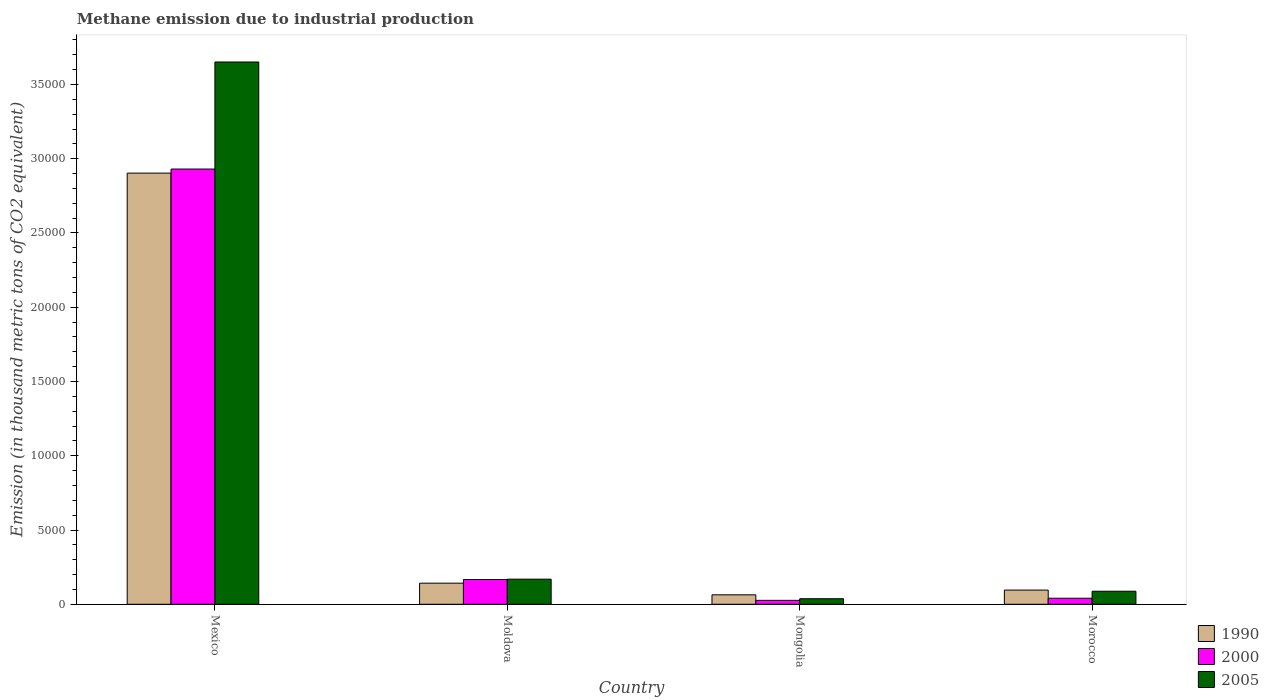How many different coloured bars are there?
Give a very brief answer. 3. How many groups of bars are there?
Your response must be concise. 4. What is the label of the 4th group of bars from the left?
Make the answer very short. Morocco. In how many cases, is the number of bars for a given country not equal to the number of legend labels?
Offer a very short reply. 0. What is the amount of methane emitted in 2000 in Mongolia?
Your answer should be very brief. 264.8. Across all countries, what is the maximum amount of methane emitted in 1990?
Your answer should be very brief. 2.90e+04. Across all countries, what is the minimum amount of methane emitted in 2000?
Offer a very short reply. 264.8. In which country was the amount of methane emitted in 2000 minimum?
Your answer should be very brief. Mongolia. What is the total amount of methane emitted in 1990 in the graph?
Your response must be concise. 3.20e+04. What is the difference between the amount of methane emitted in 1990 in Mexico and that in Moldova?
Your answer should be compact. 2.76e+04. What is the difference between the amount of methane emitted in 2000 in Moldova and the amount of methane emitted in 1990 in Morocco?
Give a very brief answer. 713.1. What is the average amount of methane emitted in 1990 per country?
Ensure brevity in your answer.  8011.43. What is the difference between the amount of methane emitted of/in 2000 and amount of methane emitted of/in 1990 in Mongolia?
Your answer should be very brief. -371.7. What is the ratio of the amount of methane emitted in 2000 in Moldova to that in Morocco?
Give a very brief answer. 4.09. Is the amount of methane emitted in 1990 in Moldova less than that in Mongolia?
Provide a succinct answer. No. What is the difference between the highest and the second highest amount of methane emitted in 1990?
Offer a very short reply. -466.9. What is the difference between the highest and the lowest amount of methane emitted in 2000?
Your response must be concise. 2.90e+04. What does the 2nd bar from the left in Morocco represents?
Provide a short and direct response. 2000. What does the 1st bar from the right in Mongolia represents?
Provide a short and direct response. 2005. Is it the case that in every country, the sum of the amount of methane emitted in 2000 and amount of methane emitted in 1990 is greater than the amount of methane emitted in 2005?
Provide a short and direct response. Yes. How many bars are there?
Your answer should be very brief. 12. Are all the bars in the graph horizontal?
Make the answer very short. No. Are the values on the major ticks of Y-axis written in scientific E-notation?
Your response must be concise. No. Does the graph contain any zero values?
Provide a succinct answer. No. Where does the legend appear in the graph?
Your response must be concise. Bottom right. What is the title of the graph?
Give a very brief answer. Methane emission due to industrial production. What is the label or title of the X-axis?
Your response must be concise. Country. What is the label or title of the Y-axis?
Offer a terse response. Emission (in thousand metric tons of CO2 equivalent). What is the Emission (in thousand metric tons of CO2 equivalent) in 1990 in Mexico?
Offer a very short reply. 2.90e+04. What is the Emission (in thousand metric tons of CO2 equivalent) in 2000 in Mexico?
Your response must be concise. 2.93e+04. What is the Emission (in thousand metric tons of CO2 equivalent) of 2005 in Mexico?
Ensure brevity in your answer.  3.65e+04. What is the Emission (in thousand metric tons of CO2 equivalent) of 1990 in Moldova?
Provide a succinct answer. 1422.3. What is the Emission (in thousand metric tons of CO2 equivalent) in 2000 in Moldova?
Offer a terse response. 1668.5. What is the Emission (in thousand metric tons of CO2 equivalent) in 2005 in Moldova?
Provide a short and direct response. 1691.1. What is the Emission (in thousand metric tons of CO2 equivalent) of 1990 in Mongolia?
Your answer should be very brief. 636.5. What is the Emission (in thousand metric tons of CO2 equivalent) of 2000 in Mongolia?
Offer a very short reply. 264.8. What is the Emission (in thousand metric tons of CO2 equivalent) of 2005 in Mongolia?
Your answer should be compact. 373.5. What is the Emission (in thousand metric tons of CO2 equivalent) in 1990 in Morocco?
Your answer should be very brief. 955.4. What is the Emission (in thousand metric tons of CO2 equivalent) of 2000 in Morocco?
Offer a very short reply. 407.6. What is the Emission (in thousand metric tons of CO2 equivalent) in 2005 in Morocco?
Keep it short and to the point. 877.7. Across all countries, what is the maximum Emission (in thousand metric tons of CO2 equivalent) in 1990?
Make the answer very short. 2.90e+04. Across all countries, what is the maximum Emission (in thousand metric tons of CO2 equivalent) of 2000?
Keep it short and to the point. 2.93e+04. Across all countries, what is the maximum Emission (in thousand metric tons of CO2 equivalent) of 2005?
Your answer should be very brief. 3.65e+04. Across all countries, what is the minimum Emission (in thousand metric tons of CO2 equivalent) in 1990?
Offer a very short reply. 636.5. Across all countries, what is the minimum Emission (in thousand metric tons of CO2 equivalent) of 2000?
Offer a terse response. 264.8. Across all countries, what is the minimum Emission (in thousand metric tons of CO2 equivalent) in 2005?
Your response must be concise. 373.5. What is the total Emission (in thousand metric tons of CO2 equivalent) in 1990 in the graph?
Your answer should be compact. 3.20e+04. What is the total Emission (in thousand metric tons of CO2 equivalent) in 2000 in the graph?
Offer a terse response. 3.16e+04. What is the total Emission (in thousand metric tons of CO2 equivalent) in 2005 in the graph?
Make the answer very short. 3.95e+04. What is the difference between the Emission (in thousand metric tons of CO2 equivalent) in 1990 in Mexico and that in Moldova?
Provide a succinct answer. 2.76e+04. What is the difference between the Emission (in thousand metric tons of CO2 equivalent) of 2000 in Mexico and that in Moldova?
Your answer should be very brief. 2.76e+04. What is the difference between the Emission (in thousand metric tons of CO2 equivalent) of 2005 in Mexico and that in Moldova?
Offer a very short reply. 3.48e+04. What is the difference between the Emission (in thousand metric tons of CO2 equivalent) of 1990 in Mexico and that in Mongolia?
Provide a succinct answer. 2.84e+04. What is the difference between the Emission (in thousand metric tons of CO2 equivalent) of 2000 in Mexico and that in Mongolia?
Your answer should be compact. 2.90e+04. What is the difference between the Emission (in thousand metric tons of CO2 equivalent) of 2005 in Mexico and that in Mongolia?
Give a very brief answer. 3.61e+04. What is the difference between the Emission (in thousand metric tons of CO2 equivalent) of 1990 in Mexico and that in Morocco?
Give a very brief answer. 2.81e+04. What is the difference between the Emission (in thousand metric tons of CO2 equivalent) in 2000 in Mexico and that in Morocco?
Provide a succinct answer. 2.89e+04. What is the difference between the Emission (in thousand metric tons of CO2 equivalent) of 2005 in Mexico and that in Morocco?
Your answer should be very brief. 3.56e+04. What is the difference between the Emission (in thousand metric tons of CO2 equivalent) of 1990 in Moldova and that in Mongolia?
Ensure brevity in your answer.  785.8. What is the difference between the Emission (in thousand metric tons of CO2 equivalent) of 2000 in Moldova and that in Mongolia?
Make the answer very short. 1403.7. What is the difference between the Emission (in thousand metric tons of CO2 equivalent) in 2005 in Moldova and that in Mongolia?
Offer a terse response. 1317.6. What is the difference between the Emission (in thousand metric tons of CO2 equivalent) in 1990 in Moldova and that in Morocco?
Provide a succinct answer. 466.9. What is the difference between the Emission (in thousand metric tons of CO2 equivalent) of 2000 in Moldova and that in Morocco?
Your answer should be compact. 1260.9. What is the difference between the Emission (in thousand metric tons of CO2 equivalent) in 2005 in Moldova and that in Morocco?
Provide a succinct answer. 813.4. What is the difference between the Emission (in thousand metric tons of CO2 equivalent) of 1990 in Mongolia and that in Morocco?
Provide a succinct answer. -318.9. What is the difference between the Emission (in thousand metric tons of CO2 equivalent) in 2000 in Mongolia and that in Morocco?
Give a very brief answer. -142.8. What is the difference between the Emission (in thousand metric tons of CO2 equivalent) of 2005 in Mongolia and that in Morocco?
Your response must be concise. -504.2. What is the difference between the Emission (in thousand metric tons of CO2 equivalent) of 1990 in Mexico and the Emission (in thousand metric tons of CO2 equivalent) of 2000 in Moldova?
Ensure brevity in your answer.  2.74e+04. What is the difference between the Emission (in thousand metric tons of CO2 equivalent) in 1990 in Mexico and the Emission (in thousand metric tons of CO2 equivalent) in 2005 in Moldova?
Make the answer very short. 2.73e+04. What is the difference between the Emission (in thousand metric tons of CO2 equivalent) in 2000 in Mexico and the Emission (in thousand metric tons of CO2 equivalent) in 2005 in Moldova?
Your answer should be compact. 2.76e+04. What is the difference between the Emission (in thousand metric tons of CO2 equivalent) of 1990 in Mexico and the Emission (in thousand metric tons of CO2 equivalent) of 2000 in Mongolia?
Offer a terse response. 2.88e+04. What is the difference between the Emission (in thousand metric tons of CO2 equivalent) of 1990 in Mexico and the Emission (in thousand metric tons of CO2 equivalent) of 2005 in Mongolia?
Your answer should be very brief. 2.87e+04. What is the difference between the Emission (in thousand metric tons of CO2 equivalent) in 2000 in Mexico and the Emission (in thousand metric tons of CO2 equivalent) in 2005 in Mongolia?
Offer a terse response. 2.89e+04. What is the difference between the Emission (in thousand metric tons of CO2 equivalent) in 1990 in Mexico and the Emission (in thousand metric tons of CO2 equivalent) in 2000 in Morocco?
Provide a short and direct response. 2.86e+04. What is the difference between the Emission (in thousand metric tons of CO2 equivalent) in 1990 in Mexico and the Emission (in thousand metric tons of CO2 equivalent) in 2005 in Morocco?
Ensure brevity in your answer.  2.82e+04. What is the difference between the Emission (in thousand metric tons of CO2 equivalent) in 2000 in Mexico and the Emission (in thousand metric tons of CO2 equivalent) in 2005 in Morocco?
Ensure brevity in your answer.  2.84e+04. What is the difference between the Emission (in thousand metric tons of CO2 equivalent) of 1990 in Moldova and the Emission (in thousand metric tons of CO2 equivalent) of 2000 in Mongolia?
Give a very brief answer. 1157.5. What is the difference between the Emission (in thousand metric tons of CO2 equivalent) in 1990 in Moldova and the Emission (in thousand metric tons of CO2 equivalent) in 2005 in Mongolia?
Your answer should be very brief. 1048.8. What is the difference between the Emission (in thousand metric tons of CO2 equivalent) in 2000 in Moldova and the Emission (in thousand metric tons of CO2 equivalent) in 2005 in Mongolia?
Offer a terse response. 1295. What is the difference between the Emission (in thousand metric tons of CO2 equivalent) of 1990 in Moldova and the Emission (in thousand metric tons of CO2 equivalent) of 2000 in Morocco?
Your answer should be very brief. 1014.7. What is the difference between the Emission (in thousand metric tons of CO2 equivalent) in 1990 in Moldova and the Emission (in thousand metric tons of CO2 equivalent) in 2005 in Morocco?
Keep it short and to the point. 544.6. What is the difference between the Emission (in thousand metric tons of CO2 equivalent) of 2000 in Moldova and the Emission (in thousand metric tons of CO2 equivalent) of 2005 in Morocco?
Your answer should be very brief. 790.8. What is the difference between the Emission (in thousand metric tons of CO2 equivalent) of 1990 in Mongolia and the Emission (in thousand metric tons of CO2 equivalent) of 2000 in Morocco?
Your answer should be compact. 228.9. What is the difference between the Emission (in thousand metric tons of CO2 equivalent) of 1990 in Mongolia and the Emission (in thousand metric tons of CO2 equivalent) of 2005 in Morocco?
Keep it short and to the point. -241.2. What is the difference between the Emission (in thousand metric tons of CO2 equivalent) in 2000 in Mongolia and the Emission (in thousand metric tons of CO2 equivalent) in 2005 in Morocco?
Your answer should be compact. -612.9. What is the average Emission (in thousand metric tons of CO2 equivalent) of 1990 per country?
Your response must be concise. 8011.43. What is the average Emission (in thousand metric tons of CO2 equivalent) in 2000 per country?
Offer a very short reply. 7911.62. What is the average Emission (in thousand metric tons of CO2 equivalent) in 2005 per country?
Keep it short and to the point. 9863.95. What is the difference between the Emission (in thousand metric tons of CO2 equivalent) of 1990 and Emission (in thousand metric tons of CO2 equivalent) of 2000 in Mexico?
Offer a very short reply. -274.1. What is the difference between the Emission (in thousand metric tons of CO2 equivalent) in 1990 and Emission (in thousand metric tons of CO2 equivalent) in 2005 in Mexico?
Ensure brevity in your answer.  -7482. What is the difference between the Emission (in thousand metric tons of CO2 equivalent) in 2000 and Emission (in thousand metric tons of CO2 equivalent) in 2005 in Mexico?
Give a very brief answer. -7207.9. What is the difference between the Emission (in thousand metric tons of CO2 equivalent) of 1990 and Emission (in thousand metric tons of CO2 equivalent) of 2000 in Moldova?
Offer a terse response. -246.2. What is the difference between the Emission (in thousand metric tons of CO2 equivalent) in 1990 and Emission (in thousand metric tons of CO2 equivalent) in 2005 in Moldova?
Give a very brief answer. -268.8. What is the difference between the Emission (in thousand metric tons of CO2 equivalent) in 2000 and Emission (in thousand metric tons of CO2 equivalent) in 2005 in Moldova?
Make the answer very short. -22.6. What is the difference between the Emission (in thousand metric tons of CO2 equivalent) in 1990 and Emission (in thousand metric tons of CO2 equivalent) in 2000 in Mongolia?
Your answer should be very brief. 371.7. What is the difference between the Emission (in thousand metric tons of CO2 equivalent) of 1990 and Emission (in thousand metric tons of CO2 equivalent) of 2005 in Mongolia?
Ensure brevity in your answer.  263. What is the difference between the Emission (in thousand metric tons of CO2 equivalent) of 2000 and Emission (in thousand metric tons of CO2 equivalent) of 2005 in Mongolia?
Ensure brevity in your answer.  -108.7. What is the difference between the Emission (in thousand metric tons of CO2 equivalent) in 1990 and Emission (in thousand metric tons of CO2 equivalent) in 2000 in Morocco?
Make the answer very short. 547.8. What is the difference between the Emission (in thousand metric tons of CO2 equivalent) in 1990 and Emission (in thousand metric tons of CO2 equivalent) in 2005 in Morocco?
Provide a short and direct response. 77.7. What is the difference between the Emission (in thousand metric tons of CO2 equivalent) of 2000 and Emission (in thousand metric tons of CO2 equivalent) of 2005 in Morocco?
Give a very brief answer. -470.1. What is the ratio of the Emission (in thousand metric tons of CO2 equivalent) in 1990 in Mexico to that in Moldova?
Offer a terse response. 20.41. What is the ratio of the Emission (in thousand metric tons of CO2 equivalent) of 2000 in Mexico to that in Moldova?
Keep it short and to the point. 17.56. What is the ratio of the Emission (in thousand metric tons of CO2 equivalent) of 2005 in Mexico to that in Moldova?
Keep it short and to the point. 21.59. What is the ratio of the Emission (in thousand metric tons of CO2 equivalent) of 1990 in Mexico to that in Mongolia?
Provide a short and direct response. 45.61. What is the ratio of the Emission (in thousand metric tons of CO2 equivalent) in 2000 in Mexico to that in Mongolia?
Keep it short and to the point. 110.67. What is the ratio of the Emission (in thousand metric tons of CO2 equivalent) of 2005 in Mexico to that in Mongolia?
Your answer should be very brief. 97.76. What is the ratio of the Emission (in thousand metric tons of CO2 equivalent) of 1990 in Mexico to that in Morocco?
Your answer should be compact. 30.39. What is the ratio of the Emission (in thousand metric tons of CO2 equivalent) of 2000 in Mexico to that in Morocco?
Make the answer very short. 71.9. What is the ratio of the Emission (in thousand metric tons of CO2 equivalent) in 2005 in Mexico to that in Morocco?
Keep it short and to the point. 41.6. What is the ratio of the Emission (in thousand metric tons of CO2 equivalent) in 1990 in Moldova to that in Mongolia?
Offer a very short reply. 2.23. What is the ratio of the Emission (in thousand metric tons of CO2 equivalent) in 2000 in Moldova to that in Mongolia?
Your answer should be compact. 6.3. What is the ratio of the Emission (in thousand metric tons of CO2 equivalent) of 2005 in Moldova to that in Mongolia?
Provide a succinct answer. 4.53. What is the ratio of the Emission (in thousand metric tons of CO2 equivalent) of 1990 in Moldova to that in Morocco?
Keep it short and to the point. 1.49. What is the ratio of the Emission (in thousand metric tons of CO2 equivalent) of 2000 in Moldova to that in Morocco?
Make the answer very short. 4.09. What is the ratio of the Emission (in thousand metric tons of CO2 equivalent) in 2005 in Moldova to that in Morocco?
Make the answer very short. 1.93. What is the ratio of the Emission (in thousand metric tons of CO2 equivalent) in 1990 in Mongolia to that in Morocco?
Offer a terse response. 0.67. What is the ratio of the Emission (in thousand metric tons of CO2 equivalent) of 2000 in Mongolia to that in Morocco?
Your answer should be very brief. 0.65. What is the ratio of the Emission (in thousand metric tons of CO2 equivalent) in 2005 in Mongolia to that in Morocco?
Give a very brief answer. 0.43. What is the difference between the highest and the second highest Emission (in thousand metric tons of CO2 equivalent) of 1990?
Your answer should be compact. 2.76e+04. What is the difference between the highest and the second highest Emission (in thousand metric tons of CO2 equivalent) of 2000?
Offer a very short reply. 2.76e+04. What is the difference between the highest and the second highest Emission (in thousand metric tons of CO2 equivalent) in 2005?
Ensure brevity in your answer.  3.48e+04. What is the difference between the highest and the lowest Emission (in thousand metric tons of CO2 equivalent) of 1990?
Provide a succinct answer. 2.84e+04. What is the difference between the highest and the lowest Emission (in thousand metric tons of CO2 equivalent) in 2000?
Provide a succinct answer. 2.90e+04. What is the difference between the highest and the lowest Emission (in thousand metric tons of CO2 equivalent) in 2005?
Offer a terse response. 3.61e+04. 